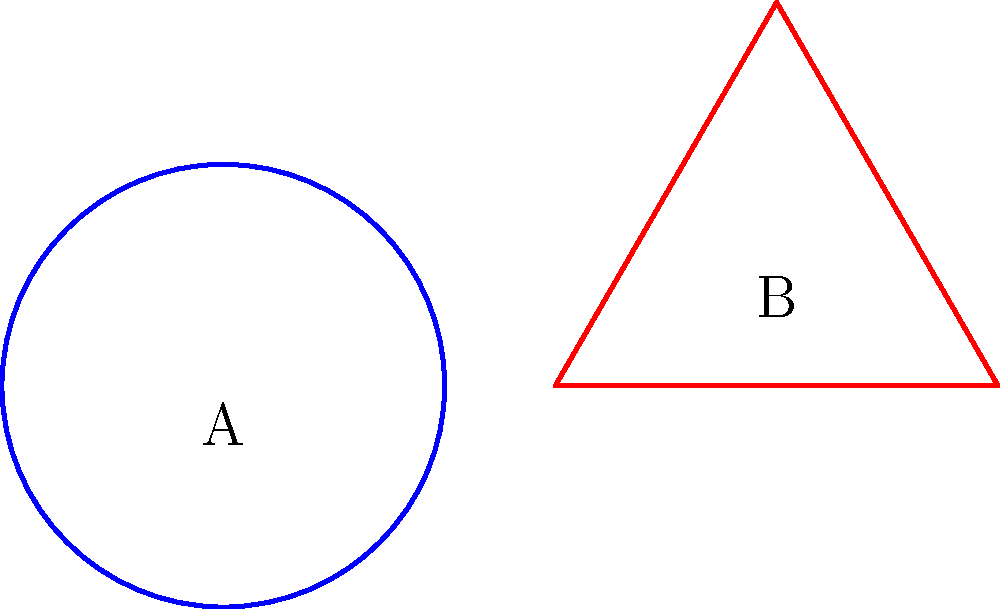Consider the following topological spaces: a circle (A) and a triangle (B). Which of the following statements about their homeomorphism is correct?

a) A and B are homeomorphic
b) A and B are not homeomorphic
c) The homeomorphism depends on the size of the shapes
d) There is insufficient information to determine the homeomorphism To determine if two topological spaces are homeomorphic, we need to consider their fundamental properties:

1. Connectedness: Both the circle and triangle are connected spaces.

2. Compactness: Both shapes are compact (closed and bounded).

3. Dimension: Both are 1-dimensional manifolds.

4. Euler characteristic: 
   - For the circle: $\chi(\text{circle}) = 0$
   - For the triangle: $\chi(\text{triangle}) = 0$ (vertices - edges + faces = 3 - 3 + 1 = 1)

5. Fundamental group:
   - The fundamental group of a circle is $\pi_1(\text{S}^1) \cong \mathbb{Z}$ (integers).
   - The fundamental group of a triangle (which is homotopy equivalent to a circle) is also $\pi_1(\text{triangle}) \cong \mathbb{Z}$.

6. Holes: Both shapes have exactly one hole.

Despite their visual differences, the circle and triangle share all these topological properties. The key insight is that we can continuously deform one into the other without tearing or gluing, which is the essence of a homeomorphism.

Therefore, the circle and triangle are indeed homeomorphic.
Answer: a) A and B are homeomorphic 